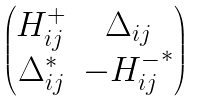Convert formula to latex. <formula><loc_0><loc_0><loc_500><loc_500>\begin{pmatrix} H _ { i j } ^ { + } & \Delta _ { i j } \\ \Delta _ { i j } ^ { * } & - { H _ { i j } ^ { - } } ^ { * } \end{pmatrix}</formula> 